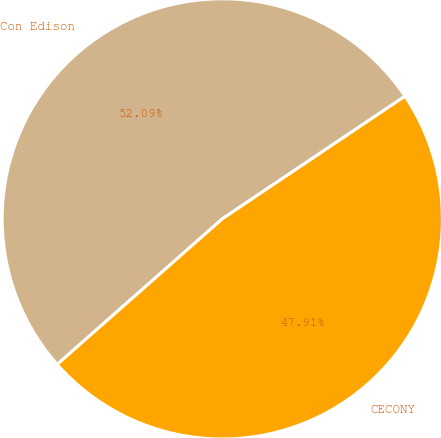Convert chart to OTSL. <chart><loc_0><loc_0><loc_500><loc_500><pie_chart><fcel>Con Edison<fcel>CECONY<nl><fcel>52.09%<fcel>47.91%<nl></chart> 